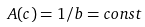Convert formula to latex. <formula><loc_0><loc_0><loc_500><loc_500>A ( c ) = 1 / b = c o n s t</formula> 